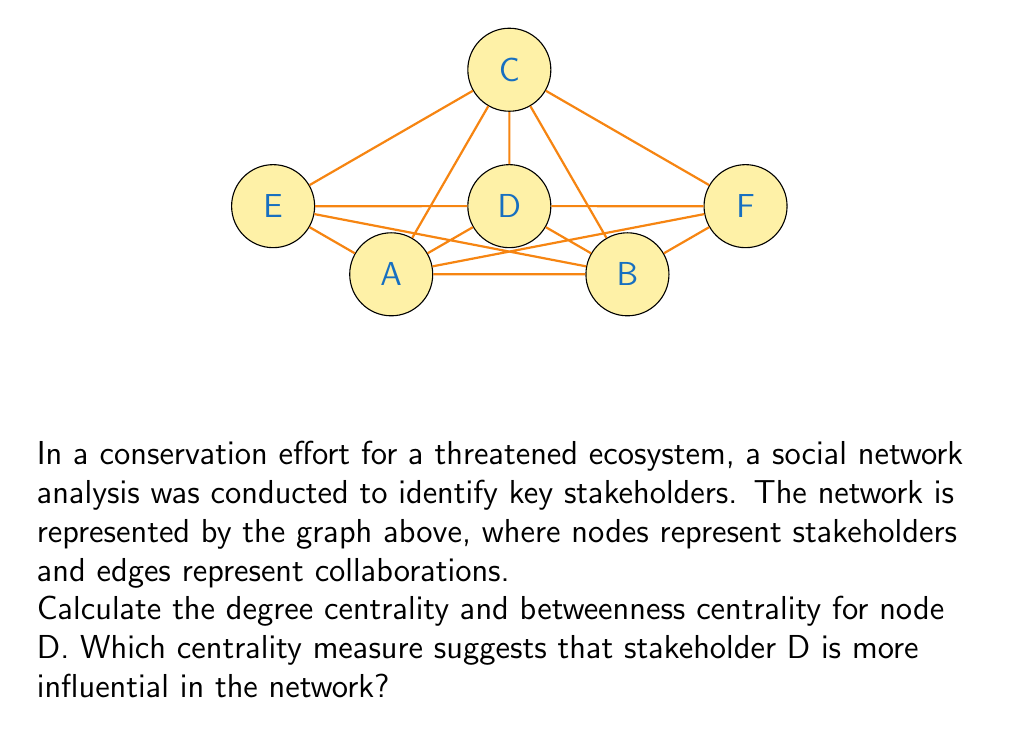Help me with this question. To solve this problem, we need to calculate both the degree centrality and betweenness centrality for node D.

1. Degree Centrality:
Degree centrality is the number of direct connections a node has. For node D:
$$\text{Degree}(D) = 5$$
To normalize this value, we divide by the maximum possible degree (n-1, where n is the total number of nodes):
$$\text{Degree Centrality}(D) = \frac{5}{5} = 1$$

2. Betweenness Centrality:
Betweenness centrality measures the extent to which a node lies on the shortest paths between other nodes. We need to calculate:
$$C_B(D) = \sum_{s \neq t \neq D} \frac{\sigma_{st}(D)}{\sigma_{st}}$$
where $\sigma_{st}$ is the total number of shortest paths from node s to node t, and $\sigma_{st}(D)$ is the number of those paths passing through D.

Calculating for each pair:
- A-B: D is not on the shortest path (0/1)
- A-C: D is on 1 of 2 shortest paths (1/2)
- A-E: D is not on the shortest path (0/1)
- A-F: D is on 1 of 2 shortest paths (1/2)
- B-C: D is on 1 of 2 shortest paths (1/2)
- B-E: D is on 1 of 2 shortest paths (1/2)
- B-F: D is not on the shortest path (0/1)
- C-E: D is on 1 of 2 shortest paths (1/2)
- C-F: D is on 1 of 2 shortest paths (1/2)
- E-F: D is on 1 of 2 shortest paths (1/2)

Sum: $4.5$

To normalize, we divide by the maximum possible betweenness:
$$(n-1)(n-2)/2 = (5)(4)/2 = 10$$

$$\text{Betweenness Centrality}(D) = \frac{4.5}{10} = 0.45$$

Comparing the two measures:
- Degree Centrality(D) = 1
- Betweenness Centrality(D) = 0.45

The degree centrality suggests that stakeholder D is more influential in the network, as it has the maximum possible normalized degree centrality of 1, indicating direct connections to all other nodes in the network.
Answer: Degree centrality (1) suggests D is more influential than betweenness centrality (0.45). 